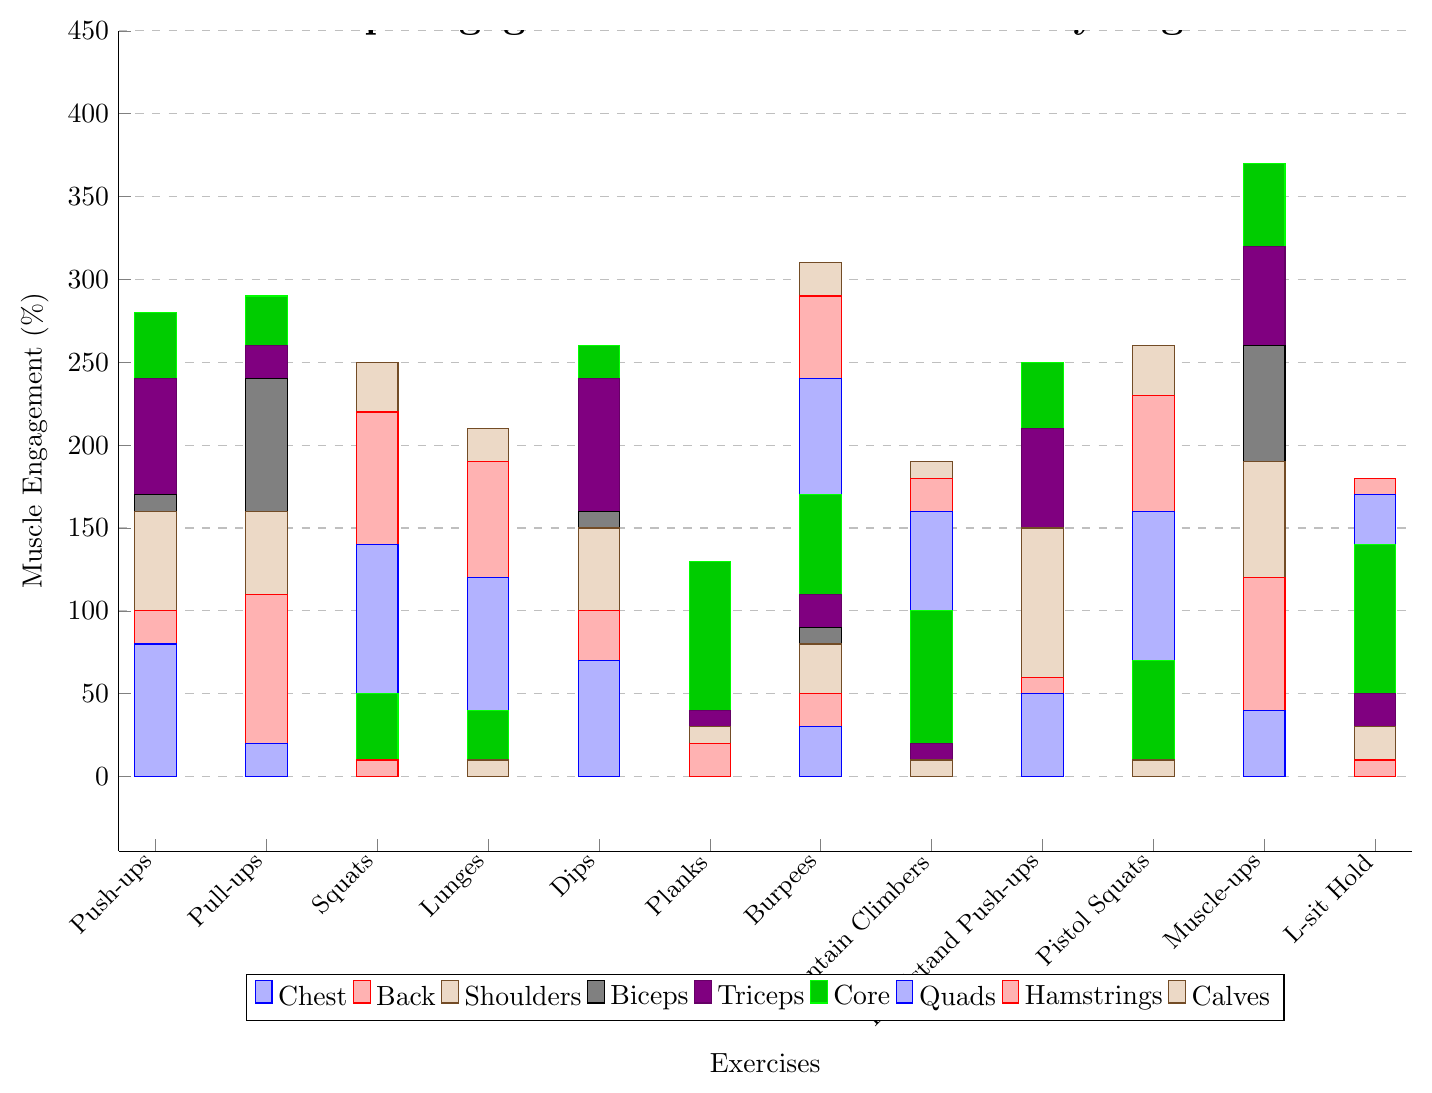Which exercise engages the chest muscles the most? The bar corresponding to Push-ups reaches the highest value for the chest category compared to other exercises.
Answer: Push-ups Which exercise engages the core muscles more: Burpees or Planks? The core muscle engagement for Burpees is higher compared to Planks because the Burpees bar reaches a higher value in the core segment.
Answer: Burpees How much higher is the back engagement for Pull-ups than Push-ups? The back engagement for Pull-ups is 90% and for Push-ups, it is 20%. The difference is 90% - 20% = 70%.
Answer: 70% What is the total muscle engagement percentage for Handstand Push-ups? Add the individual muscle engagement values for Handstand Push-ups: 50 (chest) + 10 (back) + 90 (shoulders) + 0 (biceps) + 60 (triceps) + 40 (core) + 0 (quads) + 0 (hamstrings) + 0 (calves) = 250%.
Answer: 250% Which muscle group is least engaged by Pull-ups? The biceps muscle group shows engagement for Pull-ups at 10%, the lowest among all groups for this exercise.
Answer: Biceps Between Squats and Lunges, which exercise engages the lower body muscles (quads, hamstrings, and calves) more? Sum the lower body muscle engagement for Squats: 90 (quads) + 80 (hamstrings) + 30 (calves) = 200%. Sum for Lunges: 80 (quads) + 70 (hamstrings) + 20 (calves) = 170%. Squats engage the lower body more.
Answer: Squats In which exercise do we see the highest engagement in shoulder muscles? The bar indicating Handstand Push-ups reaches the highest for shoulder muscles among all exercises.
Answer: Handstand Push-ups Which exercise shows a balanced engagement across multiple muscle groups (excluding zero engagements)? Burpees have a relatively balanced engagement across chest, back, shoulders, biceps, triceps, core, quads, hamstrings, and calves, compared to other exercises with several zeroes.
Answer: Burpees How does the muscle engagement of Dips for triceps compare to Planks for the core? The tricep engagement for Dips is 80%, while the core engagement for Planks is 90%. Therefore, Planks engage the core slightly more than Dips engage the triceps.
Answer: Planks for the core 